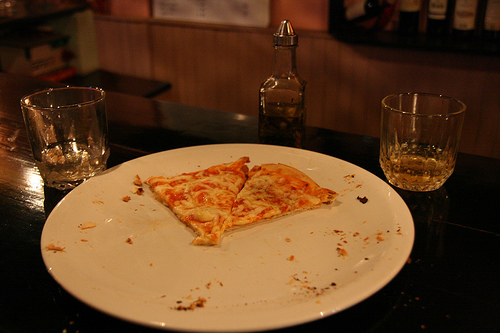Is there any cheese in the image that is orange?
Answer the question using a single word or phrase. No Do you think the cheese is white or brown? White Is the crust thin? Yes Is the pizza on the plate yellow and small? Yes What is the pizza on? Plate Is the bench in the bottom part of the photo? No Are there both pizzas and plates in this photo? Yes Do you see pizzas or doughnuts that are not yellow? No Are there either any soda cans or coffee cups in this photo? No Does that plate look white and rectangular? No Is the pizza red? No Does the glass by the plate appear to be full or empty? Empty What is filled with the liquid? Glass What is the glass near the plate filled with? Liquid Which side of the photo are the wines on? Right Is the plate orange? No In which part are the shelves? Left 